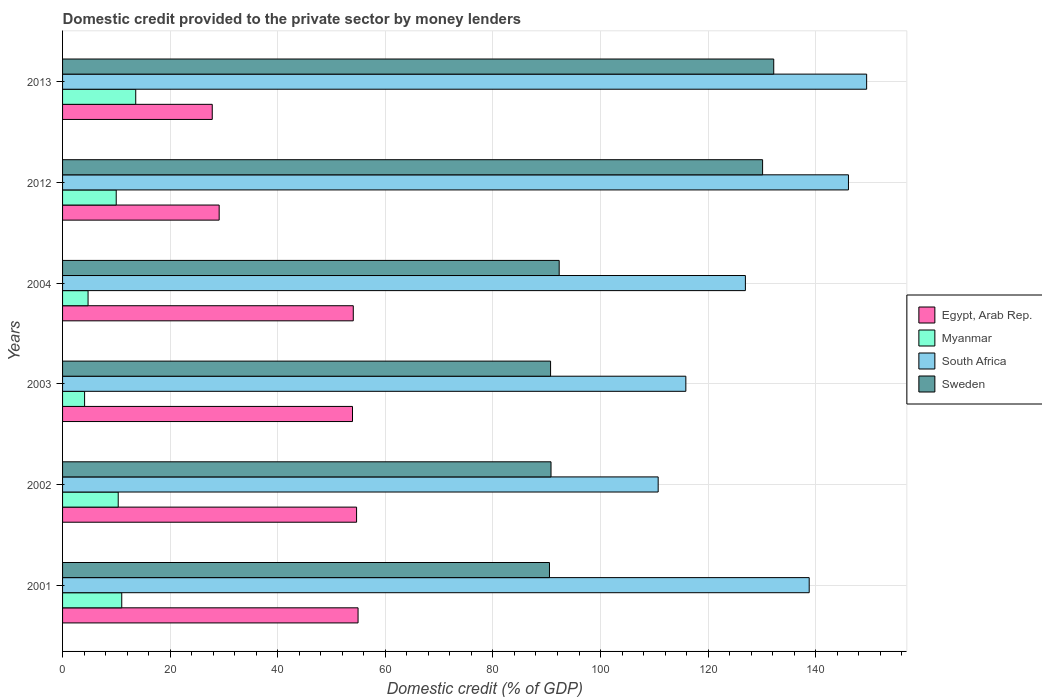How many different coloured bars are there?
Ensure brevity in your answer.  4. Are the number of bars per tick equal to the number of legend labels?
Give a very brief answer. Yes. What is the label of the 5th group of bars from the top?
Provide a succinct answer. 2002. In how many cases, is the number of bars for a given year not equal to the number of legend labels?
Keep it short and to the point. 0. What is the domestic credit provided to the private sector by money lenders in Myanmar in 2004?
Keep it short and to the point. 4.74. Across all years, what is the maximum domestic credit provided to the private sector by money lenders in Egypt, Arab Rep.?
Ensure brevity in your answer.  54.93. Across all years, what is the minimum domestic credit provided to the private sector by money lenders in Sweden?
Offer a very short reply. 90.51. In which year was the domestic credit provided to the private sector by money lenders in Myanmar maximum?
Your response must be concise. 2013. In which year was the domestic credit provided to the private sector by money lenders in South Africa minimum?
Your response must be concise. 2002. What is the total domestic credit provided to the private sector by money lenders in Sweden in the graph?
Ensure brevity in your answer.  626.67. What is the difference between the domestic credit provided to the private sector by money lenders in South Africa in 2001 and that in 2002?
Provide a short and direct response. 28.07. What is the difference between the domestic credit provided to the private sector by money lenders in Sweden in 2001 and the domestic credit provided to the private sector by money lenders in Myanmar in 2012?
Ensure brevity in your answer.  80.54. What is the average domestic credit provided to the private sector by money lenders in South Africa per year?
Give a very brief answer. 131.31. In the year 2004, what is the difference between the domestic credit provided to the private sector by money lenders in Sweden and domestic credit provided to the private sector by money lenders in Myanmar?
Provide a short and direct response. 87.58. In how many years, is the domestic credit provided to the private sector by money lenders in Egypt, Arab Rep. greater than 28 %?
Give a very brief answer. 5. What is the ratio of the domestic credit provided to the private sector by money lenders in Sweden in 2004 to that in 2013?
Your answer should be compact. 0.7. Is the difference between the domestic credit provided to the private sector by money lenders in Sweden in 2002 and 2013 greater than the difference between the domestic credit provided to the private sector by money lenders in Myanmar in 2002 and 2013?
Keep it short and to the point. No. What is the difference between the highest and the second highest domestic credit provided to the private sector by money lenders in South Africa?
Make the answer very short. 3.38. What is the difference between the highest and the lowest domestic credit provided to the private sector by money lenders in South Africa?
Offer a very short reply. 38.75. In how many years, is the domestic credit provided to the private sector by money lenders in South Africa greater than the average domestic credit provided to the private sector by money lenders in South Africa taken over all years?
Ensure brevity in your answer.  3. Is it the case that in every year, the sum of the domestic credit provided to the private sector by money lenders in Egypt, Arab Rep. and domestic credit provided to the private sector by money lenders in South Africa is greater than the sum of domestic credit provided to the private sector by money lenders in Myanmar and domestic credit provided to the private sector by money lenders in Sweden?
Offer a very short reply. Yes. What does the 2nd bar from the top in 2003 represents?
Your answer should be compact. South Africa. What does the 3rd bar from the bottom in 2003 represents?
Ensure brevity in your answer.  South Africa. Is it the case that in every year, the sum of the domestic credit provided to the private sector by money lenders in Myanmar and domestic credit provided to the private sector by money lenders in Sweden is greater than the domestic credit provided to the private sector by money lenders in South Africa?
Your answer should be very brief. No. How many bars are there?
Your answer should be compact. 24. Does the graph contain any zero values?
Offer a very short reply. No. Where does the legend appear in the graph?
Provide a short and direct response. Center right. How many legend labels are there?
Provide a short and direct response. 4. How are the legend labels stacked?
Your answer should be very brief. Vertical. What is the title of the graph?
Offer a very short reply. Domestic credit provided to the private sector by money lenders. What is the label or title of the X-axis?
Your response must be concise. Domestic credit (% of GDP). What is the Domestic credit (% of GDP) in Egypt, Arab Rep. in 2001?
Give a very brief answer. 54.93. What is the Domestic credit (% of GDP) in Myanmar in 2001?
Your answer should be very brief. 11. What is the Domestic credit (% of GDP) in South Africa in 2001?
Provide a succinct answer. 138.79. What is the Domestic credit (% of GDP) of Sweden in 2001?
Your answer should be very brief. 90.51. What is the Domestic credit (% of GDP) in Egypt, Arab Rep. in 2002?
Keep it short and to the point. 54.66. What is the Domestic credit (% of GDP) in Myanmar in 2002?
Offer a terse response. 10.34. What is the Domestic credit (% of GDP) in South Africa in 2002?
Provide a short and direct response. 110.72. What is the Domestic credit (% of GDP) in Sweden in 2002?
Offer a terse response. 90.8. What is the Domestic credit (% of GDP) in Egypt, Arab Rep. in 2003?
Your answer should be very brief. 53.9. What is the Domestic credit (% of GDP) of Myanmar in 2003?
Your response must be concise. 4.1. What is the Domestic credit (% of GDP) of South Africa in 2003?
Your answer should be compact. 115.86. What is the Domestic credit (% of GDP) in Sweden in 2003?
Keep it short and to the point. 90.72. What is the Domestic credit (% of GDP) of Egypt, Arab Rep. in 2004?
Ensure brevity in your answer.  54.04. What is the Domestic credit (% of GDP) of Myanmar in 2004?
Your response must be concise. 4.74. What is the Domestic credit (% of GDP) in South Africa in 2004?
Give a very brief answer. 126.93. What is the Domestic credit (% of GDP) of Sweden in 2004?
Provide a short and direct response. 92.32. What is the Domestic credit (% of GDP) of Egypt, Arab Rep. in 2012?
Ensure brevity in your answer.  29.11. What is the Domestic credit (% of GDP) in Myanmar in 2012?
Offer a terse response. 9.97. What is the Domestic credit (% of GDP) of South Africa in 2012?
Your response must be concise. 146.09. What is the Domestic credit (% of GDP) of Sweden in 2012?
Your answer should be very brief. 130.13. What is the Domestic credit (% of GDP) of Egypt, Arab Rep. in 2013?
Offer a terse response. 27.82. What is the Domestic credit (% of GDP) in Myanmar in 2013?
Offer a very short reply. 13.6. What is the Domestic credit (% of GDP) of South Africa in 2013?
Your answer should be very brief. 149.47. What is the Domestic credit (% of GDP) in Sweden in 2013?
Ensure brevity in your answer.  132.2. Across all years, what is the maximum Domestic credit (% of GDP) in Egypt, Arab Rep.?
Make the answer very short. 54.93. Across all years, what is the maximum Domestic credit (% of GDP) of Myanmar?
Keep it short and to the point. 13.6. Across all years, what is the maximum Domestic credit (% of GDP) in South Africa?
Your answer should be very brief. 149.47. Across all years, what is the maximum Domestic credit (% of GDP) in Sweden?
Offer a terse response. 132.2. Across all years, what is the minimum Domestic credit (% of GDP) of Egypt, Arab Rep.?
Your answer should be very brief. 27.82. Across all years, what is the minimum Domestic credit (% of GDP) in Myanmar?
Your answer should be compact. 4.1. Across all years, what is the minimum Domestic credit (% of GDP) of South Africa?
Ensure brevity in your answer.  110.72. Across all years, what is the minimum Domestic credit (% of GDP) in Sweden?
Your answer should be very brief. 90.51. What is the total Domestic credit (% of GDP) in Egypt, Arab Rep. in the graph?
Ensure brevity in your answer.  274.46. What is the total Domestic credit (% of GDP) of Myanmar in the graph?
Your answer should be compact. 53.76. What is the total Domestic credit (% of GDP) in South Africa in the graph?
Provide a succinct answer. 787.87. What is the total Domestic credit (% of GDP) of Sweden in the graph?
Your answer should be compact. 626.67. What is the difference between the Domestic credit (% of GDP) of Egypt, Arab Rep. in 2001 and that in 2002?
Ensure brevity in your answer.  0.28. What is the difference between the Domestic credit (% of GDP) of Myanmar in 2001 and that in 2002?
Ensure brevity in your answer.  0.66. What is the difference between the Domestic credit (% of GDP) in South Africa in 2001 and that in 2002?
Offer a terse response. 28.07. What is the difference between the Domestic credit (% of GDP) in Sweden in 2001 and that in 2002?
Offer a very short reply. -0.29. What is the difference between the Domestic credit (% of GDP) in Egypt, Arab Rep. in 2001 and that in 2003?
Offer a terse response. 1.03. What is the difference between the Domestic credit (% of GDP) in Myanmar in 2001 and that in 2003?
Keep it short and to the point. 6.91. What is the difference between the Domestic credit (% of GDP) in South Africa in 2001 and that in 2003?
Make the answer very short. 22.93. What is the difference between the Domestic credit (% of GDP) of Sweden in 2001 and that in 2003?
Offer a very short reply. -0.21. What is the difference between the Domestic credit (% of GDP) of Egypt, Arab Rep. in 2001 and that in 2004?
Make the answer very short. 0.89. What is the difference between the Domestic credit (% of GDP) of Myanmar in 2001 and that in 2004?
Provide a succinct answer. 6.26. What is the difference between the Domestic credit (% of GDP) of South Africa in 2001 and that in 2004?
Provide a succinct answer. 11.86. What is the difference between the Domestic credit (% of GDP) of Sweden in 2001 and that in 2004?
Ensure brevity in your answer.  -1.81. What is the difference between the Domestic credit (% of GDP) of Egypt, Arab Rep. in 2001 and that in 2012?
Provide a succinct answer. 25.82. What is the difference between the Domestic credit (% of GDP) in Myanmar in 2001 and that in 2012?
Your response must be concise. 1.03. What is the difference between the Domestic credit (% of GDP) of South Africa in 2001 and that in 2012?
Your response must be concise. -7.3. What is the difference between the Domestic credit (% of GDP) in Sweden in 2001 and that in 2012?
Provide a succinct answer. -39.62. What is the difference between the Domestic credit (% of GDP) of Egypt, Arab Rep. in 2001 and that in 2013?
Your answer should be very brief. 27.11. What is the difference between the Domestic credit (% of GDP) of Myanmar in 2001 and that in 2013?
Provide a succinct answer. -2.6. What is the difference between the Domestic credit (% of GDP) in South Africa in 2001 and that in 2013?
Make the answer very short. -10.68. What is the difference between the Domestic credit (% of GDP) in Sweden in 2001 and that in 2013?
Offer a very short reply. -41.69. What is the difference between the Domestic credit (% of GDP) of Egypt, Arab Rep. in 2002 and that in 2003?
Ensure brevity in your answer.  0.76. What is the difference between the Domestic credit (% of GDP) of Myanmar in 2002 and that in 2003?
Make the answer very short. 6.25. What is the difference between the Domestic credit (% of GDP) in South Africa in 2002 and that in 2003?
Offer a very short reply. -5.14. What is the difference between the Domestic credit (% of GDP) of Sweden in 2002 and that in 2003?
Make the answer very short. 0.08. What is the difference between the Domestic credit (% of GDP) of Egypt, Arab Rep. in 2002 and that in 2004?
Give a very brief answer. 0.61. What is the difference between the Domestic credit (% of GDP) in Myanmar in 2002 and that in 2004?
Provide a succinct answer. 5.6. What is the difference between the Domestic credit (% of GDP) of South Africa in 2002 and that in 2004?
Offer a terse response. -16.21. What is the difference between the Domestic credit (% of GDP) in Sweden in 2002 and that in 2004?
Give a very brief answer. -1.52. What is the difference between the Domestic credit (% of GDP) in Egypt, Arab Rep. in 2002 and that in 2012?
Provide a succinct answer. 25.54. What is the difference between the Domestic credit (% of GDP) of Myanmar in 2002 and that in 2012?
Offer a very short reply. 0.37. What is the difference between the Domestic credit (% of GDP) of South Africa in 2002 and that in 2012?
Your response must be concise. -35.37. What is the difference between the Domestic credit (% of GDP) of Sweden in 2002 and that in 2012?
Keep it short and to the point. -39.33. What is the difference between the Domestic credit (% of GDP) in Egypt, Arab Rep. in 2002 and that in 2013?
Your answer should be very brief. 26.83. What is the difference between the Domestic credit (% of GDP) in Myanmar in 2002 and that in 2013?
Provide a short and direct response. -3.26. What is the difference between the Domestic credit (% of GDP) of South Africa in 2002 and that in 2013?
Keep it short and to the point. -38.75. What is the difference between the Domestic credit (% of GDP) of Sweden in 2002 and that in 2013?
Your answer should be very brief. -41.4. What is the difference between the Domestic credit (% of GDP) of Egypt, Arab Rep. in 2003 and that in 2004?
Your response must be concise. -0.15. What is the difference between the Domestic credit (% of GDP) of Myanmar in 2003 and that in 2004?
Offer a very short reply. -0.64. What is the difference between the Domestic credit (% of GDP) of South Africa in 2003 and that in 2004?
Give a very brief answer. -11.07. What is the difference between the Domestic credit (% of GDP) of Sweden in 2003 and that in 2004?
Provide a short and direct response. -1.6. What is the difference between the Domestic credit (% of GDP) in Egypt, Arab Rep. in 2003 and that in 2012?
Give a very brief answer. 24.78. What is the difference between the Domestic credit (% of GDP) of Myanmar in 2003 and that in 2012?
Keep it short and to the point. -5.88. What is the difference between the Domestic credit (% of GDP) of South Africa in 2003 and that in 2012?
Give a very brief answer. -30.23. What is the difference between the Domestic credit (% of GDP) of Sweden in 2003 and that in 2012?
Keep it short and to the point. -39.41. What is the difference between the Domestic credit (% of GDP) in Egypt, Arab Rep. in 2003 and that in 2013?
Offer a very short reply. 26.07. What is the difference between the Domestic credit (% of GDP) in Myanmar in 2003 and that in 2013?
Provide a short and direct response. -9.51. What is the difference between the Domestic credit (% of GDP) of South Africa in 2003 and that in 2013?
Ensure brevity in your answer.  -33.61. What is the difference between the Domestic credit (% of GDP) in Sweden in 2003 and that in 2013?
Provide a short and direct response. -41.48. What is the difference between the Domestic credit (% of GDP) in Egypt, Arab Rep. in 2004 and that in 2012?
Give a very brief answer. 24.93. What is the difference between the Domestic credit (% of GDP) in Myanmar in 2004 and that in 2012?
Your answer should be very brief. -5.23. What is the difference between the Domestic credit (% of GDP) of South Africa in 2004 and that in 2012?
Offer a very short reply. -19.16. What is the difference between the Domestic credit (% of GDP) of Sweden in 2004 and that in 2012?
Keep it short and to the point. -37.81. What is the difference between the Domestic credit (% of GDP) in Egypt, Arab Rep. in 2004 and that in 2013?
Provide a short and direct response. 26.22. What is the difference between the Domestic credit (% of GDP) in Myanmar in 2004 and that in 2013?
Your answer should be very brief. -8.86. What is the difference between the Domestic credit (% of GDP) of South Africa in 2004 and that in 2013?
Offer a terse response. -22.54. What is the difference between the Domestic credit (% of GDP) of Sweden in 2004 and that in 2013?
Provide a succinct answer. -39.88. What is the difference between the Domestic credit (% of GDP) of Egypt, Arab Rep. in 2012 and that in 2013?
Offer a very short reply. 1.29. What is the difference between the Domestic credit (% of GDP) of Myanmar in 2012 and that in 2013?
Your answer should be compact. -3.63. What is the difference between the Domestic credit (% of GDP) in South Africa in 2012 and that in 2013?
Offer a terse response. -3.38. What is the difference between the Domestic credit (% of GDP) in Sweden in 2012 and that in 2013?
Your answer should be compact. -2.07. What is the difference between the Domestic credit (% of GDP) in Egypt, Arab Rep. in 2001 and the Domestic credit (% of GDP) in Myanmar in 2002?
Keep it short and to the point. 44.59. What is the difference between the Domestic credit (% of GDP) of Egypt, Arab Rep. in 2001 and the Domestic credit (% of GDP) of South Africa in 2002?
Your response must be concise. -55.79. What is the difference between the Domestic credit (% of GDP) of Egypt, Arab Rep. in 2001 and the Domestic credit (% of GDP) of Sweden in 2002?
Provide a succinct answer. -35.87. What is the difference between the Domestic credit (% of GDP) of Myanmar in 2001 and the Domestic credit (% of GDP) of South Africa in 2002?
Make the answer very short. -99.72. What is the difference between the Domestic credit (% of GDP) of Myanmar in 2001 and the Domestic credit (% of GDP) of Sweden in 2002?
Offer a very short reply. -79.8. What is the difference between the Domestic credit (% of GDP) in South Africa in 2001 and the Domestic credit (% of GDP) in Sweden in 2002?
Offer a very short reply. 47.99. What is the difference between the Domestic credit (% of GDP) of Egypt, Arab Rep. in 2001 and the Domestic credit (% of GDP) of Myanmar in 2003?
Offer a terse response. 50.84. What is the difference between the Domestic credit (% of GDP) of Egypt, Arab Rep. in 2001 and the Domestic credit (% of GDP) of South Africa in 2003?
Ensure brevity in your answer.  -60.93. What is the difference between the Domestic credit (% of GDP) of Egypt, Arab Rep. in 2001 and the Domestic credit (% of GDP) of Sweden in 2003?
Make the answer very short. -35.79. What is the difference between the Domestic credit (% of GDP) in Myanmar in 2001 and the Domestic credit (% of GDP) in South Africa in 2003?
Provide a short and direct response. -104.86. What is the difference between the Domestic credit (% of GDP) in Myanmar in 2001 and the Domestic credit (% of GDP) in Sweden in 2003?
Your answer should be compact. -79.71. What is the difference between the Domestic credit (% of GDP) in South Africa in 2001 and the Domestic credit (% of GDP) in Sweden in 2003?
Your answer should be very brief. 48.08. What is the difference between the Domestic credit (% of GDP) in Egypt, Arab Rep. in 2001 and the Domestic credit (% of GDP) in Myanmar in 2004?
Give a very brief answer. 50.19. What is the difference between the Domestic credit (% of GDP) in Egypt, Arab Rep. in 2001 and the Domestic credit (% of GDP) in South Africa in 2004?
Your answer should be very brief. -72. What is the difference between the Domestic credit (% of GDP) in Egypt, Arab Rep. in 2001 and the Domestic credit (% of GDP) in Sweden in 2004?
Keep it short and to the point. -37.39. What is the difference between the Domestic credit (% of GDP) in Myanmar in 2001 and the Domestic credit (% of GDP) in South Africa in 2004?
Provide a short and direct response. -115.93. What is the difference between the Domestic credit (% of GDP) in Myanmar in 2001 and the Domestic credit (% of GDP) in Sweden in 2004?
Offer a very short reply. -81.31. What is the difference between the Domestic credit (% of GDP) in South Africa in 2001 and the Domestic credit (% of GDP) in Sweden in 2004?
Keep it short and to the point. 46.48. What is the difference between the Domestic credit (% of GDP) of Egypt, Arab Rep. in 2001 and the Domestic credit (% of GDP) of Myanmar in 2012?
Your answer should be compact. 44.96. What is the difference between the Domestic credit (% of GDP) in Egypt, Arab Rep. in 2001 and the Domestic credit (% of GDP) in South Africa in 2012?
Provide a short and direct response. -91.16. What is the difference between the Domestic credit (% of GDP) of Egypt, Arab Rep. in 2001 and the Domestic credit (% of GDP) of Sweden in 2012?
Your answer should be very brief. -75.2. What is the difference between the Domestic credit (% of GDP) of Myanmar in 2001 and the Domestic credit (% of GDP) of South Africa in 2012?
Ensure brevity in your answer.  -135.09. What is the difference between the Domestic credit (% of GDP) of Myanmar in 2001 and the Domestic credit (% of GDP) of Sweden in 2012?
Ensure brevity in your answer.  -119.13. What is the difference between the Domestic credit (% of GDP) in South Africa in 2001 and the Domestic credit (% of GDP) in Sweden in 2012?
Ensure brevity in your answer.  8.66. What is the difference between the Domestic credit (% of GDP) in Egypt, Arab Rep. in 2001 and the Domestic credit (% of GDP) in Myanmar in 2013?
Ensure brevity in your answer.  41.33. What is the difference between the Domestic credit (% of GDP) of Egypt, Arab Rep. in 2001 and the Domestic credit (% of GDP) of South Africa in 2013?
Your answer should be very brief. -94.54. What is the difference between the Domestic credit (% of GDP) of Egypt, Arab Rep. in 2001 and the Domestic credit (% of GDP) of Sweden in 2013?
Offer a very short reply. -77.27. What is the difference between the Domestic credit (% of GDP) in Myanmar in 2001 and the Domestic credit (% of GDP) in South Africa in 2013?
Offer a terse response. -138.47. What is the difference between the Domestic credit (% of GDP) of Myanmar in 2001 and the Domestic credit (% of GDP) of Sweden in 2013?
Offer a very short reply. -121.2. What is the difference between the Domestic credit (% of GDP) in South Africa in 2001 and the Domestic credit (% of GDP) in Sweden in 2013?
Your answer should be very brief. 6.59. What is the difference between the Domestic credit (% of GDP) of Egypt, Arab Rep. in 2002 and the Domestic credit (% of GDP) of Myanmar in 2003?
Ensure brevity in your answer.  50.56. What is the difference between the Domestic credit (% of GDP) in Egypt, Arab Rep. in 2002 and the Domestic credit (% of GDP) in South Africa in 2003?
Keep it short and to the point. -61.21. What is the difference between the Domestic credit (% of GDP) of Egypt, Arab Rep. in 2002 and the Domestic credit (% of GDP) of Sweden in 2003?
Your response must be concise. -36.06. What is the difference between the Domestic credit (% of GDP) of Myanmar in 2002 and the Domestic credit (% of GDP) of South Africa in 2003?
Provide a short and direct response. -105.52. What is the difference between the Domestic credit (% of GDP) of Myanmar in 2002 and the Domestic credit (% of GDP) of Sweden in 2003?
Your answer should be compact. -80.37. What is the difference between the Domestic credit (% of GDP) in South Africa in 2002 and the Domestic credit (% of GDP) in Sweden in 2003?
Ensure brevity in your answer.  20. What is the difference between the Domestic credit (% of GDP) in Egypt, Arab Rep. in 2002 and the Domestic credit (% of GDP) in Myanmar in 2004?
Keep it short and to the point. 49.92. What is the difference between the Domestic credit (% of GDP) in Egypt, Arab Rep. in 2002 and the Domestic credit (% of GDP) in South Africa in 2004?
Your response must be concise. -72.28. What is the difference between the Domestic credit (% of GDP) in Egypt, Arab Rep. in 2002 and the Domestic credit (% of GDP) in Sweden in 2004?
Keep it short and to the point. -37.66. What is the difference between the Domestic credit (% of GDP) in Myanmar in 2002 and the Domestic credit (% of GDP) in South Africa in 2004?
Your response must be concise. -116.59. What is the difference between the Domestic credit (% of GDP) in Myanmar in 2002 and the Domestic credit (% of GDP) in Sweden in 2004?
Provide a succinct answer. -81.97. What is the difference between the Domestic credit (% of GDP) in South Africa in 2002 and the Domestic credit (% of GDP) in Sweden in 2004?
Your answer should be compact. 18.4. What is the difference between the Domestic credit (% of GDP) in Egypt, Arab Rep. in 2002 and the Domestic credit (% of GDP) in Myanmar in 2012?
Your answer should be compact. 44.68. What is the difference between the Domestic credit (% of GDP) in Egypt, Arab Rep. in 2002 and the Domestic credit (% of GDP) in South Africa in 2012?
Provide a short and direct response. -91.43. What is the difference between the Domestic credit (% of GDP) of Egypt, Arab Rep. in 2002 and the Domestic credit (% of GDP) of Sweden in 2012?
Keep it short and to the point. -75.47. What is the difference between the Domestic credit (% of GDP) of Myanmar in 2002 and the Domestic credit (% of GDP) of South Africa in 2012?
Offer a terse response. -135.74. What is the difference between the Domestic credit (% of GDP) in Myanmar in 2002 and the Domestic credit (% of GDP) in Sweden in 2012?
Give a very brief answer. -119.78. What is the difference between the Domestic credit (% of GDP) in South Africa in 2002 and the Domestic credit (% of GDP) in Sweden in 2012?
Provide a succinct answer. -19.41. What is the difference between the Domestic credit (% of GDP) in Egypt, Arab Rep. in 2002 and the Domestic credit (% of GDP) in Myanmar in 2013?
Make the answer very short. 41.05. What is the difference between the Domestic credit (% of GDP) of Egypt, Arab Rep. in 2002 and the Domestic credit (% of GDP) of South Africa in 2013?
Provide a short and direct response. -94.82. What is the difference between the Domestic credit (% of GDP) of Egypt, Arab Rep. in 2002 and the Domestic credit (% of GDP) of Sweden in 2013?
Your answer should be very brief. -77.54. What is the difference between the Domestic credit (% of GDP) in Myanmar in 2002 and the Domestic credit (% of GDP) in South Africa in 2013?
Your answer should be very brief. -139.13. What is the difference between the Domestic credit (% of GDP) of Myanmar in 2002 and the Domestic credit (% of GDP) of Sweden in 2013?
Make the answer very short. -121.85. What is the difference between the Domestic credit (% of GDP) of South Africa in 2002 and the Domestic credit (% of GDP) of Sweden in 2013?
Offer a terse response. -21.48. What is the difference between the Domestic credit (% of GDP) in Egypt, Arab Rep. in 2003 and the Domestic credit (% of GDP) in Myanmar in 2004?
Your answer should be compact. 49.16. What is the difference between the Domestic credit (% of GDP) of Egypt, Arab Rep. in 2003 and the Domestic credit (% of GDP) of South Africa in 2004?
Your response must be concise. -73.03. What is the difference between the Domestic credit (% of GDP) of Egypt, Arab Rep. in 2003 and the Domestic credit (% of GDP) of Sweden in 2004?
Ensure brevity in your answer.  -38.42. What is the difference between the Domestic credit (% of GDP) of Myanmar in 2003 and the Domestic credit (% of GDP) of South Africa in 2004?
Offer a terse response. -122.84. What is the difference between the Domestic credit (% of GDP) in Myanmar in 2003 and the Domestic credit (% of GDP) in Sweden in 2004?
Keep it short and to the point. -88.22. What is the difference between the Domestic credit (% of GDP) of South Africa in 2003 and the Domestic credit (% of GDP) of Sweden in 2004?
Provide a short and direct response. 23.55. What is the difference between the Domestic credit (% of GDP) of Egypt, Arab Rep. in 2003 and the Domestic credit (% of GDP) of Myanmar in 2012?
Provide a succinct answer. 43.92. What is the difference between the Domestic credit (% of GDP) in Egypt, Arab Rep. in 2003 and the Domestic credit (% of GDP) in South Africa in 2012?
Make the answer very short. -92.19. What is the difference between the Domestic credit (% of GDP) in Egypt, Arab Rep. in 2003 and the Domestic credit (% of GDP) in Sweden in 2012?
Provide a short and direct response. -76.23. What is the difference between the Domestic credit (% of GDP) in Myanmar in 2003 and the Domestic credit (% of GDP) in South Africa in 2012?
Your response must be concise. -141.99. What is the difference between the Domestic credit (% of GDP) of Myanmar in 2003 and the Domestic credit (% of GDP) of Sweden in 2012?
Your response must be concise. -126.03. What is the difference between the Domestic credit (% of GDP) of South Africa in 2003 and the Domestic credit (% of GDP) of Sweden in 2012?
Your response must be concise. -14.27. What is the difference between the Domestic credit (% of GDP) in Egypt, Arab Rep. in 2003 and the Domestic credit (% of GDP) in Myanmar in 2013?
Keep it short and to the point. 40.3. What is the difference between the Domestic credit (% of GDP) of Egypt, Arab Rep. in 2003 and the Domestic credit (% of GDP) of South Africa in 2013?
Ensure brevity in your answer.  -95.57. What is the difference between the Domestic credit (% of GDP) in Egypt, Arab Rep. in 2003 and the Domestic credit (% of GDP) in Sweden in 2013?
Offer a very short reply. -78.3. What is the difference between the Domestic credit (% of GDP) of Myanmar in 2003 and the Domestic credit (% of GDP) of South Africa in 2013?
Offer a terse response. -145.38. What is the difference between the Domestic credit (% of GDP) in Myanmar in 2003 and the Domestic credit (% of GDP) in Sweden in 2013?
Keep it short and to the point. -128.1. What is the difference between the Domestic credit (% of GDP) in South Africa in 2003 and the Domestic credit (% of GDP) in Sweden in 2013?
Make the answer very short. -16.34. What is the difference between the Domestic credit (% of GDP) of Egypt, Arab Rep. in 2004 and the Domestic credit (% of GDP) of Myanmar in 2012?
Your answer should be very brief. 44.07. What is the difference between the Domestic credit (% of GDP) of Egypt, Arab Rep. in 2004 and the Domestic credit (% of GDP) of South Africa in 2012?
Make the answer very short. -92.05. What is the difference between the Domestic credit (% of GDP) of Egypt, Arab Rep. in 2004 and the Domestic credit (% of GDP) of Sweden in 2012?
Give a very brief answer. -76.09. What is the difference between the Domestic credit (% of GDP) in Myanmar in 2004 and the Domestic credit (% of GDP) in South Africa in 2012?
Ensure brevity in your answer.  -141.35. What is the difference between the Domestic credit (% of GDP) in Myanmar in 2004 and the Domestic credit (% of GDP) in Sweden in 2012?
Keep it short and to the point. -125.39. What is the difference between the Domestic credit (% of GDP) of South Africa in 2004 and the Domestic credit (% of GDP) of Sweden in 2012?
Provide a short and direct response. -3.2. What is the difference between the Domestic credit (% of GDP) in Egypt, Arab Rep. in 2004 and the Domestic credit (% of GDP) in Myanmar in 2013?
Your answer should be very brief. 40.44. What is the difference between the Domestic credit (% of GDP) in Egypt, Arab Rep. in 2004 and the Domestic credit (% of GDP) in South Africa in 2013?
Give a very brief answer. -95.43. What is the difference between the Domestic credit (% of GDP) of Egypt, Arab Rep. in 2004 and the Domestic credit (% of GDP) of Sweden in 2013?
Keep it short and to the point. -78.16. What is the difference between the Domestic credit (% of GDP) in Myanmar in 2004 and the Domestic credit (% of GDP) in South Africa in 2013?
Give a very brief answer. -144.73. What is the difference between the Domestic credit (% of GDP) in Myanmar in 2004 and the Domestic credit (% of GDP) in Sweden in 2013?
Your answer should be very brief. -127.46. What is the difference between the Domestic credit (% of GDP) in South Africa in 2004 and the Domestic credit (% of GDP) in Sweden in 2013?
Offer a very short reply. -5.27. What is the difference between the Domestic credit (% of GDP) of Egypt, Arab Rep. in 2012 and the Domestic credit (% of GDP) of Myanmar in 2013?
Offer a very short reply. 15.51. What is the difference between the Domestic credit (% of GDP) in Egypt, Arab Rep. in 2012 and the Domestic credit (% of GDP) in South Africa in 2013?
Your response must be concise. -120.36. What is the difference between the Domestic credit (% of GDP) in Egypt, Arab Rep. in 2012 and the Domestic credit (% of GDP) in Sweden in 2013?
Keep it short and to the point. -103.09. What is the difference between the Domestic credit (% of GDP) of Myanmar in 2012 and the Domestic credit (% of GDP) of South Africa in 2013?
Your response must be concise. -139.5. What is the difference between the Domestic credit (% of GDP) of Myanmar in 2012 and the Domestic credit (% of GDP) of Sweden in 2013?
Offer a terse response. -122.23. What is the difference between the Domestic credit (% of GDP) of South Africa in 2012 and the Domestic credit (% of GDP) of Sweden in 2013?
Your response must be concise. 13.89. What is the average Domestic credit (% of GDP) of Egypt, Arab Rep. per year?
Offer a terse response. 45.74. What is the average Domestic credit (% of GDP) in Myanmar per year?
Offer a very short reply. 8.96. What is the average Domestic credit (% of GDP) in South Africa per year?
Offer a terse response. 131.31. What is the average Domestic credit (% of GDP) of Sweden per year?
Provide a succinct answer. 104.45. In the year 2001, what is the difference between the Domestic credit (% of GDP) of Egypt, Arab Rep. and Domestic credit (% of GDP) of Myanmar?
Ensure brevity in your answer.  43.93. In the year 2001, what is the difference between the Domestic credit (% of GDP) in Egypt, Arab Rep. and Domestic credit (% of GDP) in South Africa?
Offer a very short reply. -83.86. In the year 2001, what is the difference between the Domestic credit (% of GDP) of Egypt, Arab Rep. and Domestic credit (% of GDP) of Sweden?
Your answer should be very brief. -35.58. In the year 2001, what is the difference between the Domestic credit (% of GDP) in Myanmar and Domestic credit (% of GDP) in South Africa?
Offer a very short reply. -127.79. In the year 2001, what is the difference between the Domestic credit (% of GDP) in Myanmar and Domestic credit (% of GDP) in Sweden?
Keep it short and to the point. -79.51. In the year 2001, what is the difference between the Domestic credit (% of GDP) in South Africa and Domestic credit (% of GDP) in Sweden?
Offer a very short reply. 48.28. In the year 2002, what is the difference between the Domestic credit (% of GDP) in Egypt, Arab Rep. and Domestic credit (% of GDP) in Myanmar?
Your response must be concise. 44.31. In the year 2002, what is the difference between the Domestic credit (% of GDP) in Egypt, Arab Rep. and Domestic credit (% of GDP) in South Africa?
Provide a short and direct response. -56.06. In the year 2002, what is the difference between the Domestic credit (% of GDP) in Egypt, Arab Rep. and Domestic credit (% of GDP) in Sweden?
Provide a short and direct response. -36.14. In the year 2002, what is the difference between the Domestic credit (% of GDP) in Myanmar and Domestic credit (% of GDP) in South Africa?
Offer a very short reply. -100.37. In the year 2002, what is the difference between the Domestic credit (% of GDP) of Myanmar and Domestic credit (% of GDP) of Sweden?
Offer a very short reply. -80.45. In the year 2002, what is the difference between the Domestic credit (% of GDP) in South Africa and Domestic credit (% of GDP) in Sweden?
Give a very brief answer. 19.92. In the year 2003, what is the difference between the Domestic credit (% of GDP) in Egypt, Arab Rep. and Domestic credit (% of GDP) in Myanmar?
Make the answer very short. 49.8. In the year 2003, what is the difference between the Domestic credit (% of GDP) in Egypt, Arab Rep. and Domestic credit (% of GDP) in South Africa?
Keep it short and to the point. -61.96. In the year 2003, what is the difference between the Domestic credit (% of GDP) of Egypt, Arab Rep. and Domestic credit (% of GDP) of Sweden?
Give a very brief answer. -36.82. In the year 2003, what is the difference between the Domestic credit (% of GDP) in Myanmar and Domestic credit (% of GDP) in South Africa?
Your answer should be compact. -111.77. In the year 2003, what is the difference between the Domestic credit (% of GDP) in Myanmar and Domestic credit (% of GDP) in Sweden?
Give a very brief answer. -86.62. In the year 2003, what is the difference between the Domestic credit (% of GDP) in South Africa and Domestic credit (% of GDP) in Sweden?
Keep it short and to the point. 25.15. In the year 2004, what is the difference between the Domestic credit (% of GDP) in Egypt, Arab Rep. and Domestic credit (% of GDP) in Myanmar?
Keep it short and to the point. 49.3. In the year 2004, what is the difference between the Domestic credit (% of GDP) in Egypt, Arab Rep. and Domestic credit (% of GDP) in South Africa?
Make the answer very short. -72.89. In the year 2004, what is the difference between the Domestic credit (% of GDP) of Egypt, Arab Rep. and Domestic credit (% of GDP) of Sweden?
Offer a very short reply. -38.27. In the year 2004, what is the difference between the Domestic credit (% of GDP) in Myanmar and Domestic credit (% of GDP) in South Africa?
Give a very brief answer. -122.19. In the year 2004, what is the difference between the Domestic credit (% of GDP) of Myanmar and Domestic credit (% of GDP) of Sweden?
Ensure brevity in your answer.  -87.58. In the year 2004, what is the difference between the Domestic credit (% of GDP) in South Africa and Domestic credit (% of GDP) in Sweden?
Ensure brevity in your answer.  34.62. In the year 2012, what is the difference between the Domestic credit (% of GDP) in Egypt, Arab Rep. and Domestic credit (% of GDP) in Myanmar?
Keep it short and to the point. 19.14. In the year 2012, what is the difference between the Domestic credit (% of GDP) in Egypt, Arab Rep. and Domestic credit (% of GDP) in South Africa?
Provide a short and direct response. -116.98. In the year 2012, what is the difference between the Domestic credit (% of GDP) in Egypt, Arab Rep. and Domestic credit (% of GDP) in Sweden?
Give a very brief answer. -101.02. In the year 2012, what is the difference between the Domestic credit (% of GDP) of Myanmar and Domestic credit (% of GDP) of South Africa?
Give a very brief answer. -136.12. In the year 2012, what is the difference between the Domestic credit (% of GDP) of Myanmar and Domestic credit (% of GDP) of Sweden?
Offer a terse response. -120.16. In the year 2012, what is the difference between the Domestic credit (% of GDP) in South Africa and Domestic credit (% of GDP) in Sweden?
Make the answer very short. 15.96. In the year 2013, what is the difference between the Domestic credit (% of GDP) of Egypt, Arab Rep. and Domestic credit (% of GDP) of Myanmar?
Offer a very short reply. 14.22. In the year 2013, what is the difference between the Domestic credit (% of GDP) in Egypt, Arab Rep. and Domestic credit (% of GDP) in South Africa?
Make the answer very short. -121.65. In the year 2013, what is the difference between the Domestic credit (% of GDP) of Egypt, Arab Rep. and Domestic credit (% of GDP) of Sweden?
Provide a short and direct response. -104.38. In the year 2013, what is the difference between the Domestic credit (% of GDP) of Myanmar and Domestic credit (% of GDP) of South Africa?
Give a very brief answer. -135.87. In the year 2013, what is the difference between the Domestic credit (% of GDP) of Myanmar and Domestic credit (% of GDP) of Sweden?
Keep it short and to the point. -118.6. In the year 2013, what is the difference between the Domestic credit (% of GDP) in South Africa and Domestic credit (% of GDP) in Sweden?
Make the answer very short. 17.27. What is the ratio of the Domestic credit (% of GDP) of Egypt, Arab Rep. in 2001 to that in 2002?
Your answer should be compact. 1. What is the ratio of the Domestic credit (% of GDP) in Myanmar in 2001 to that in 2002?
Ensure brevity in your answer.  1.06. What is the ratio of the Domestic credit (% of GDP) in South Africa in 2001 to that in 2002?
Keep it short and to the point. 1.25. What is the ratio of the Domestic credit (% of GDP) of Sweden in 2001 to that in 2002?
Offer a very short reply. 1. What is the ratio of the Domestic credit (% of GDP) in Egypt, Arab Rep. in 2001 to that in 2003?
Provide a short and direct response. 1.02. What is the ratio of the Domestic credit (% of GDP) of Myanmar in 2001 to that in 2003?
Offer a very short reply. 2.69. What is the ratio of the Domestic credit (% of GDP) in South Africa in 2001 to that in 2003?
Give a very brief answer. 1.2. What is the ratio of the Domestic credit (% of GDP) of Sweden in 2001 to that in 2003?
Your response must be concise. 1. What is the ratio of the Domestic credit (% of GDP) in Egypt, Arab Rep. in 2001 to that in 2004?
Your answer should be compact. 1.02. What is the ratio of the Domestic credit (% of GDP) of Myanmar in 2001 to that in 2004?
Provide a succinct answer. 2.32. What is the ratio of the Domestic credit (% of GDP) of South Africa in 2001 to that in 2004?
Keep it short and to the point. 1.09. What is the ratio of the Domestic credit (% of GDP) in Sweden in 2001 to that in 2004?
Your answer should be compact. 0.98. What is the ratio of the Domestic credit (% of GDP) in Egypt, Arab Rep. in 2001 to that in 2012?
Your response must be concise. 1.89. What is the ratio of the Domestic credit (% of GDP) of Myanmar in 2001 to that in 2012?
Offer a terse response. 1.1. What is the ratio of the Domestic credit (% of GDP) in South Africa in 2001 to that in 2012?
Provide a succinct answer. 0.95. What is the ratio of the Domestic credit (% of GDP) of Sweden in 2001 to that in 2012?
Offer a very short reply. 0.7. What is the ratio of the Domestic credit (% of GDP) of Egypt, Arab Rep. in 2001 to that in 2013?
Your response must be concise. 1.97. What is the ratio of the Domestic credit (% of GDP) of Myanmar in 2001 to that in 2013?
Keep it short and to the point. 0.81. What is the ratio of the Domestic credit (% of GDP) in Sweden in 2001 to that in 2013?
Provide a succinct answer. 0.68. What is the ratio of the Domestic credit (% of GDP) in Egypt, Arab Rep. in 2002 to that in 2003?
Ensure brevity in your answer.  1.01. What is the ratio of the Domestic credit (% of GDP) in Myanmar in 2002 to that in 2003?
Make the answer very short. 2.53. What is the ratio of the Domestic credit (% of GDP) in South Africa in 2002 to that in 2003?
Provide a succinct answer. 0.96. What is the ratio of the Domestic credit (% of GDP) of Sweden in 2002 to that in 2003?
Offer a terse response. 1. What is the ratio of the Domestic credit (% of GDP) in Egypt, Arab Rep. in 2002 to that in 2004?
Give a very brief answer. 1.01. What is the ratio of the Domestic credit (% of GDP) of Myanmar in 2002 to that in 2004?
Offer a terse response. 2.18. What is the ratio of the Domestic credit (% of GDP) of South Africa in 2002 to that in 2004?
Your answer should be compact. 0.87. What is the ratio of the Domestic credit (% of GDP) of Sweden in 2002 to that in 2004?
Make the answer very short. 0.98. What is the ratio of the Domestic credit (% of GDP) in Egypt, Arab Rep. in 2002 to that in 2012?
Provide a succinct answer. 1.88. What is the ratio of the Domestic credit (% of GDP) in Myanmar in 2002 to that in 2012?
Offer a very short reply. 1.04. What is the ratio of the Domestic credit (% of GDP) of South Africa in 2002 to that in 2012?
Give a very brief answer. 0.76. What is the ratio of the Domestic credit (% of GDP) of Sweden in 2002 to that in 2012?
Offer a very short reply. 0.7. What is the ratio of the Domestic credit (% of GDP) in Egypt, Arab Rep. in 2002 to that in 2013?
Make the answer very short. 1.96. What is the ratio of the Domestic credit (% of GDP) of Myanmar in 2002 to that in 2013?
Your response must be concise. 0.76. What is the ratio of the Domestic credit (% of GDP) in South Africa in 2002 to that in 2013?
Keep it short and to the point. 0.74. What is the ratio of the Domestic credit (% of GDP) in Sweden in 2002 to that in 2013?
Keep it short and to the point. 0.69. What is the ratio of the Domestic credit (% of GDP) of Egypt, Arab Rep. in 2003 to that in 2004?
Provide a succinct answer. 1. What is the ratio of the Domestic credit (% of GDP) of Myanmar in 2003 to that in 2004?
Your answer should be very brief. 0.86. What is the ratio of the Domestic credit (% of GDP) in South Africa in 2003 to that in 2004?
Offer a very short reply. 0.91. What is the ratio of the Domestic credit (% of GDP) in Sweden in 2003 to that in 2004?
Provide a short and direct response. 0.98. What is the ratio of the Domestic credit (% of GDP) of Egypt, Arab Rep. in 2003 to that in 2012?
Offer a very short reply. 1.85. What is the ratio of the Domestic credit (% of GDP) in Myanmar in 2003 to that in 2012?
Your answer should be compact. 0.41. What is the ratio of the Domestic credit (% of GDP) in South Africa in 2003 to that in 2012?
Keep it short and to the point. 0.79. What is the ratio of the Domestic credit (% of GDP) of Sweden in 2003 to that in 2012?
Your answer should be very brief. 0.7. What is the ratio of the Domestic credit (% of GDP) in Egypt, Arab Rep. in 2003 to that in 2013?
Offer a very short reply. 1.94. What is the ratio of the Domestic credit (% of GDP) of Myanmar in 2003 to that in 2013?
Provide a succinct answer. 0.3. What is the ratio of the Domestic credit (% of GDP) of South Africa in 2003 to that in 2013?
Give a very brief answer. 0.78. What is the ratio of the Domestic credit (% of GDP) of Sweden in 2003 to that in 2013?
Offer a terse response. 0.69. What is the ratio of the Domestic credit (% of GDP) in Egypt, Arab Rep. in 2004 to that in 2012?
Keep it short and to the point. 1.86. What is the ratio of the Domestic credit (% of GDP) of Myanmar in 2004 to that in 2012?
Make the answer very short. 0.48. What is the ratio of the Domestic credit (% of GDP) in South Africa in 2004 to that in 2012?
Your answer should be very brief. 0.87. What is the ratio of the Domestic credit (% of GDP) in Sweden in 2004 to that in 2012?
Offer a very short reply. 0.71. What is the ratio of the Domestic credit (% of GDP) in Egypt, Arab Rep. in 2004 to that in 2013?
Ensure brevity in your answer.  1.94. What is the ratio of the Domestic credit (% of GDP) of Myanmar in 2004 to that in 2013?
Your answer should be very brief. 0.35. What is the ratio of the Domestic credit (% of GDP) in South Africa in 2004 to that in 2013?
Give a very brief answer. 0.85. What is the ratio of the Domestic credit (% of GDP) in Sweden in 2004 to that in 2013?
Offer a very short reply. 0.7. What is the ratio of the Domestic credit (% of GDP) in Egypt, Arab Rep. in 2012 to that in 2013?
Provide a short and direct response. 1.05. What is the ratio of the Domestic credit (% of GDP) of Myanmar in 2012 to that in 2013?
Your answer should be very brief. 0.73. What is the ratio of the Domestic credit (% of GDP) in South Africa in 2012 to that in 2013?
Provide a short and direct response. 0.98. What is the ratio of the Domestic credit (% of GDP) in Sweden in 2012 to that in 2013?
Provide a short and direct response. 0.98. What is the difference between the highest and the second highest Domestic credit (% of GDP) of Egypt, Arab Rep.?
Keep it short and to the point. 0.28. What is the difference between the highest and the second highest Domestic credit (% of GDP) of Myanmar?
Your response must be concise. 2.6. What is the difference between the highest and the second highest Domestic credit (% of GDP) of South Africa?
Give a very brief answer. 3.38. What is the difference between the highest and the second highest Domestic credit (% of GDP) in Sweden?
Make the answer very short. 2.07. What is the difference between the highest and the lowest Domestic credit (% of GDP) in Egypt, Arab Rep.?
Offer a terse response. 27.11. What is the difference between the highest and the lowest Domestic credit (% of GDP) of Myanmar?
Keep it short and to the point. 9.51. What is the difference between the highest and the lowest Domestic credit (% of GDP) of South Africa?
Provide a short and direct response. 38.75. What is the difference between the highest and the lowest Domestic credit (% of GDP) of Sweden?
Your answer should be compact. 41.69. 